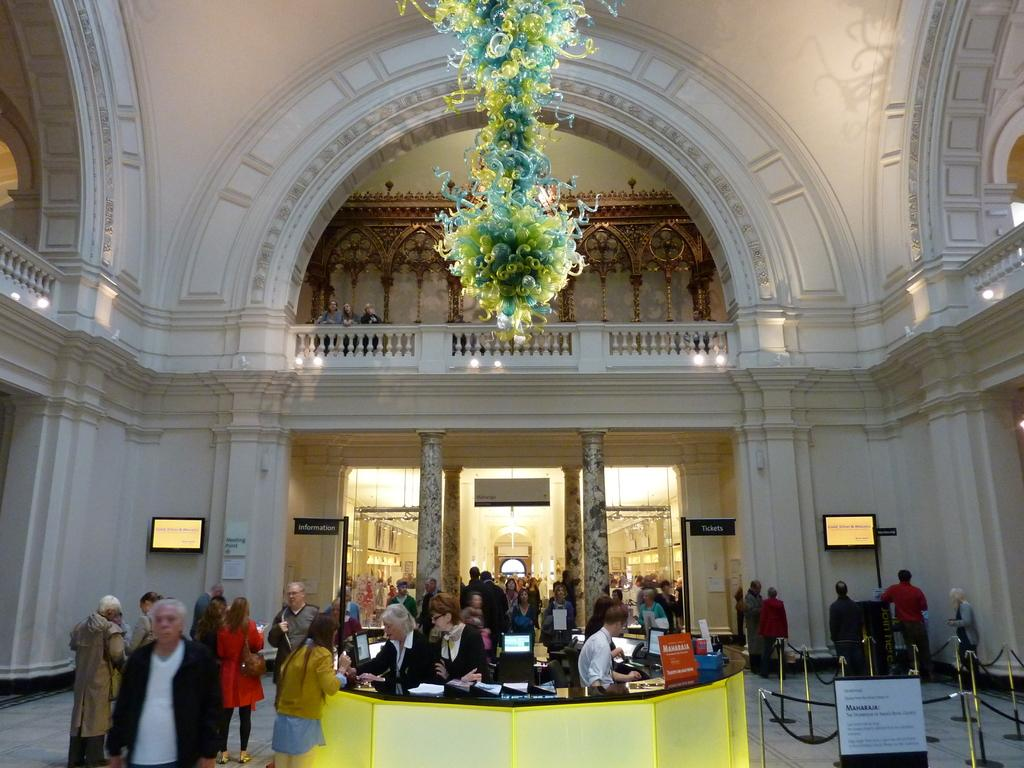What can be seen at the bottom of the image? At the bottom of the image, there are many people, monitors, papers, and posters. What are the main features in the middle of the image? In the middle of the image, there are some people, lights, decorations, and a wall. Are there any architectural elements in the image? Yes, there are pillars in the image. What type of insurance is being discussed by the people in the image? There is no indication in the image that the people are discussing insurance. What kind of fruit can be seen on the table in the middle of the image? There is no fruit present in the image; it features people, lights, decorations, and a wall in the middle. 